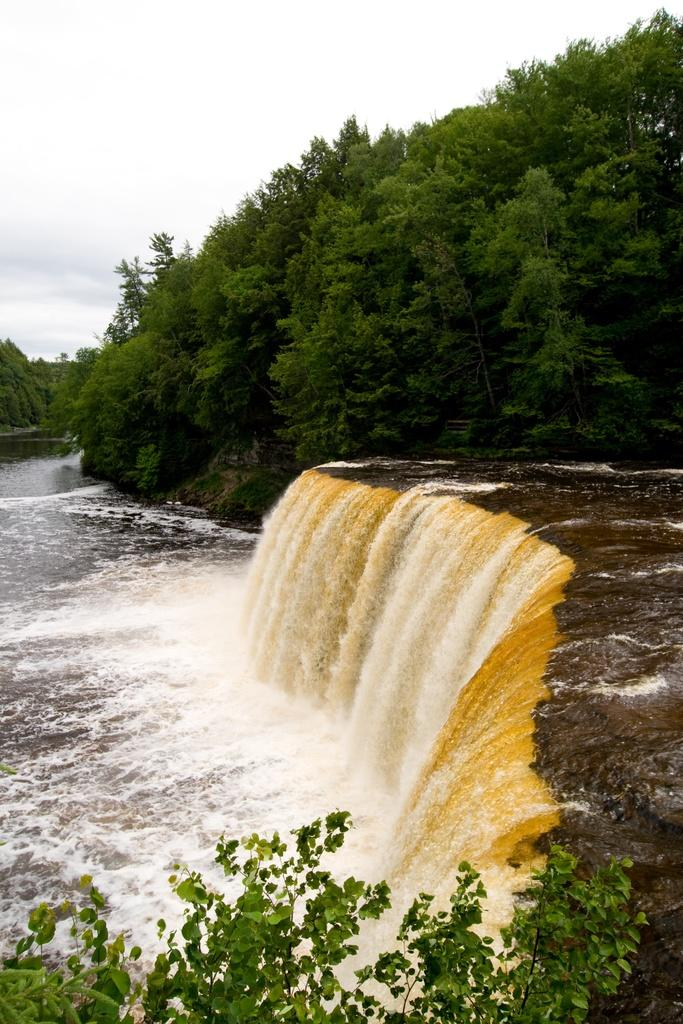What natural feature is the main subject of the image? There is a waterfall in the image. What is located in front of the waterfall? There are plants in front of the waterfall. What can be seen in the background of the image? There are trees and the sky visible in the background of the image. Can you tell me how many cats are sitting on the waterfall in the image? There are no cats present in the image; it features a waterfall with plants in front and trees and sky in the background. 